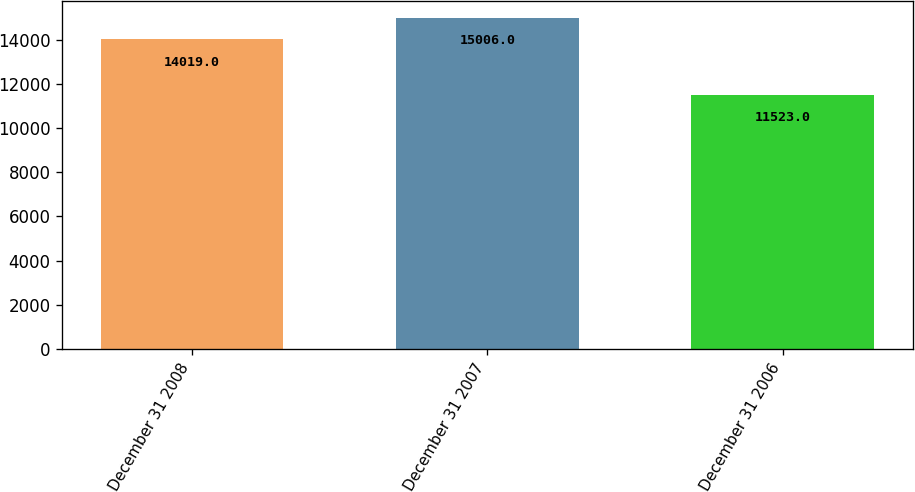Convert chart. <chart><loc_0><loc_0><loc_500><loc_500><bar_chart><fcel>December 31 2008<fcel>December 31 2007<fcel>December 31 2006<nl><fcel>14019<fcel>15006<fcel>11523<nl></chart> 